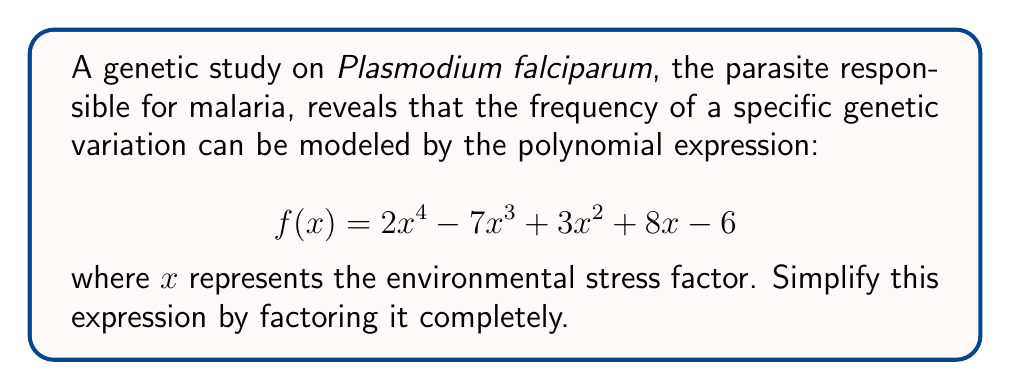Could you help me with this problem? To factor this polynomial completely, we'll follow these steps:

1) First, check for any common factors. In this case, there are no common factors for all terms.

2) Next, we can try to group the terms:
   $$ f(x) = (2x^4 - 7x^3) + (3x^2 + 8x - 6) $$

3) Factor out the common factor from the first two terms:
   $$ f(x) = x^3(2x - 7) + (3x^2 + 8x - 6) $$

4) Now, we need to factor the quadratic expression $(3x^2 + 8x - 6)$. We can do this using the quadratic formula or by inspection. By inspection, we can see that this factors to:
   $$ 3x^2 + 8x - 6 = (3x - 2)(x + 3) $$

5) Substituting this back into our expression:
   $$ f(x) = x^3(2x - 7) + (3x - 2)(x + 3) $$

6) To factor further, we need to find a common factor between $x^3(2x - 7)$ and $(3x - 2)(x + 3)$. We can see that $(x - 1)$ is a factor of both:

   $x^3(2x - 7) = x^3(2x - 2 - 5) = x^3(2(x - 1) - 5) = x^3(2(x - 1) - 5)$
   $(3x - 2)(x + 3) = (3x - 3 + 1)(x + 3) = (3(x - 1) + 1)(x + 3)$

7) Factor out $(x - 1)$:
   $$ f(x) = (x - 1)(2x^3 - 5x^2 + 3x + 6) $$

8) The cubic expression $(2x^3 - 5x^2 + 3x + 6)$ doesn't factor further.

Therefore, the fully factored expression is:
$$ f(x) = (x - 1)(2x^3 - 5x^2 + 3x + 6) $$
Answer: $$ f(x) = (x - 1)(2x^3 - 5x^2 + 3x + 6) $$ 